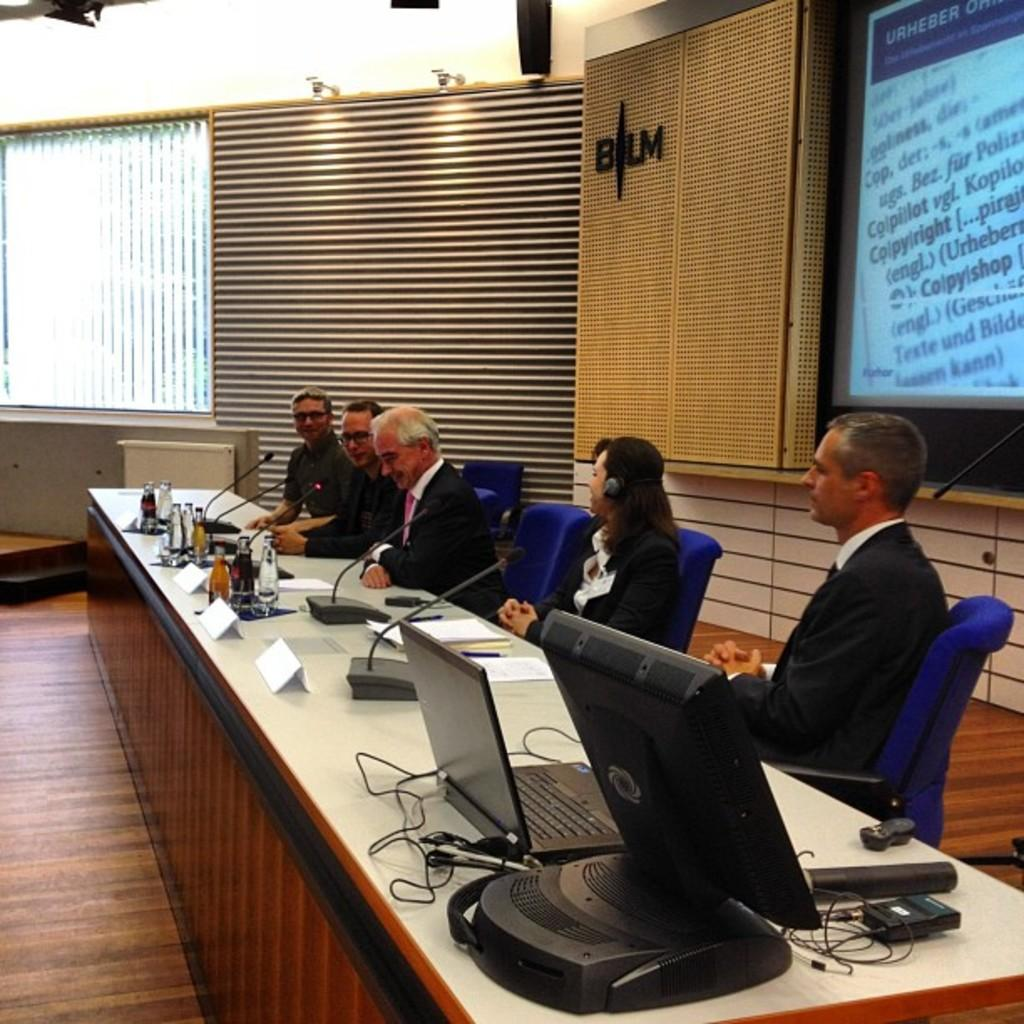<image>
Relay a brief, clear account of the picture shown. a group pf people with the letters BLM behind them 